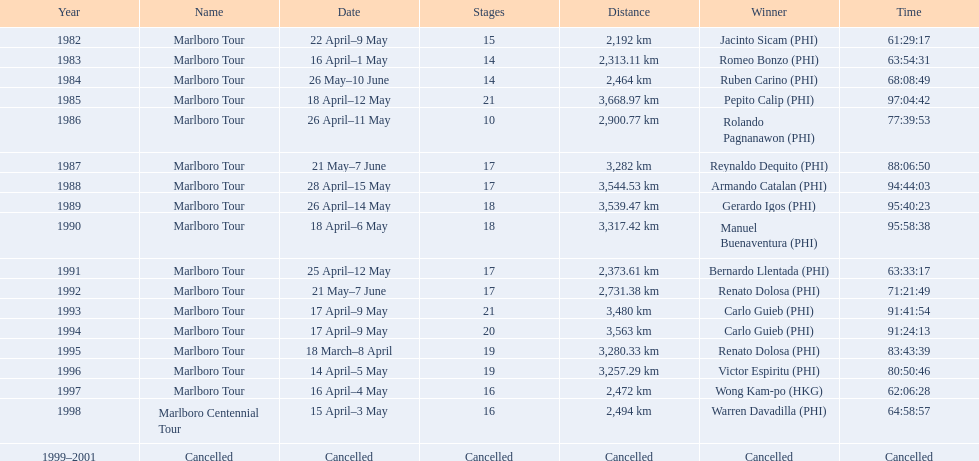What are the distances travelled on the tour? 2,192 km, 2,313.11 km, 2,464 km, 3,668.97 km, 2,900.77 km, 3,282 km, 3,544.53 km, 3,539.47 km, 3,317.42 km, 2,373.61 km, 2,731.38 km, 3,480 km, 3,563 km, 3,280.33 km, 3,257.29 km, 2,472 km, 2,494 km. Which of these are the largest? 3,668.97 km. 